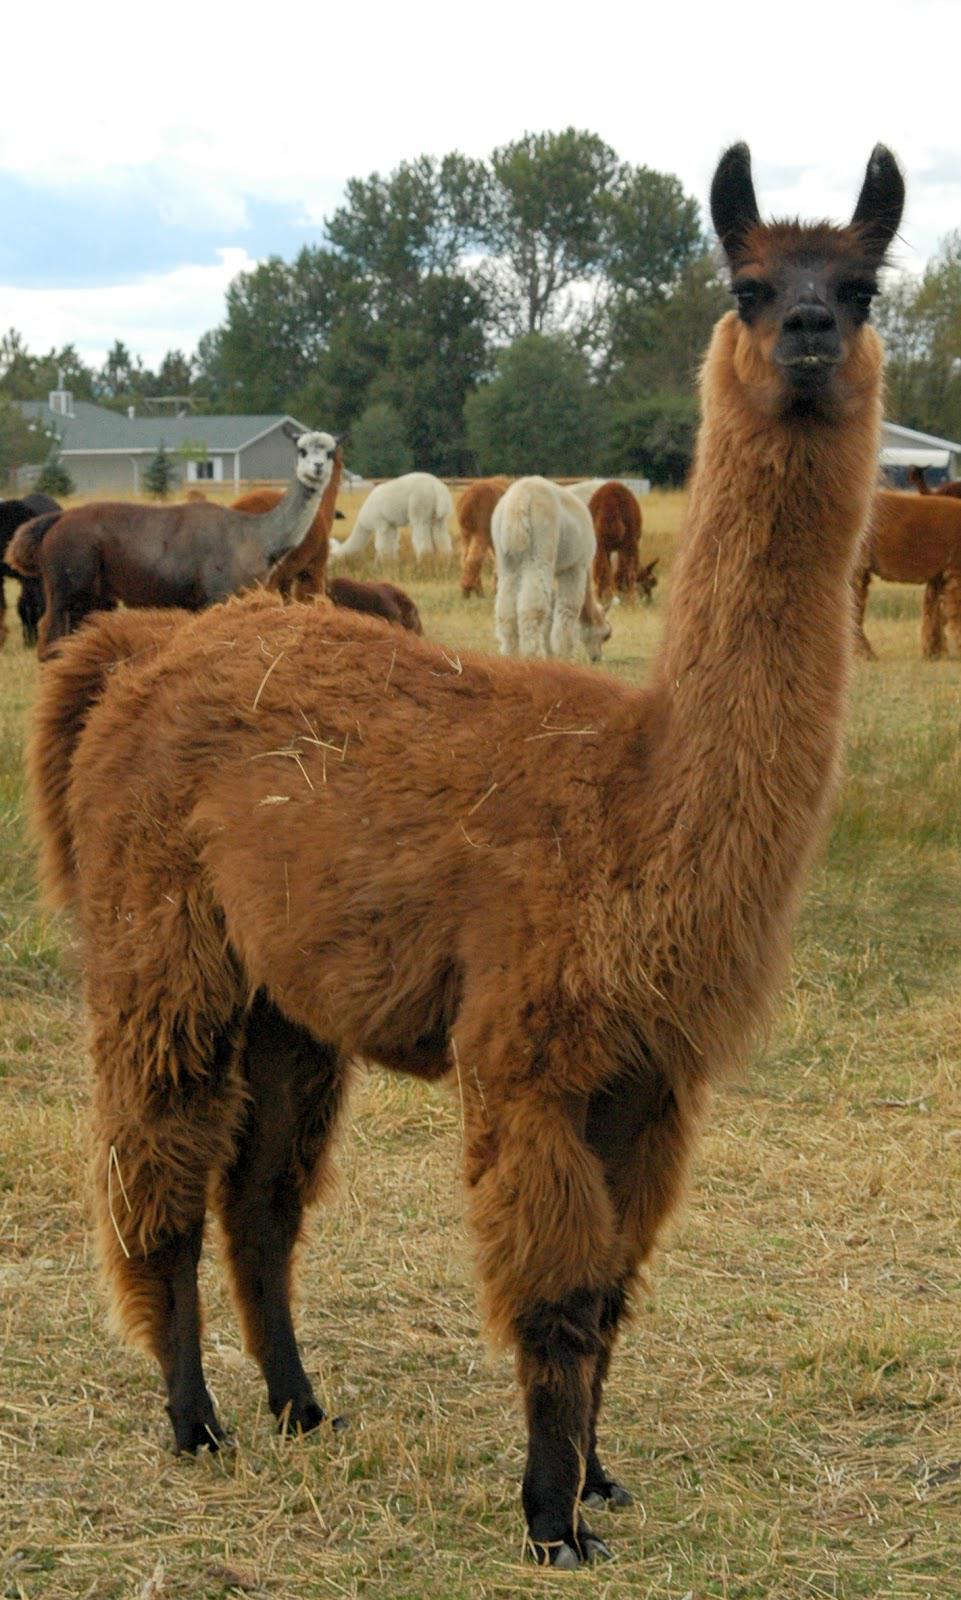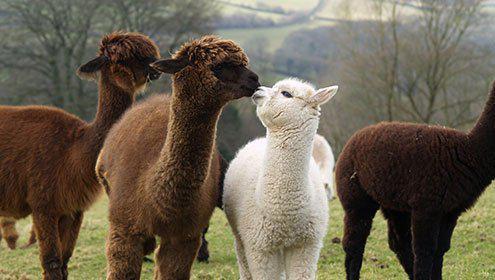The first image is the image on the left, the second image is the image on the right. Given the left and right images, does the statement "At least one photo shows an animal that has had the hair on its neck shaved, and every photo has at least three animals." hold true? Answer yes or no. No. The first image is the image on the left, the second image is the image on the right. Given the left and right images, does the statement "At least some of the llamas have shaved necks." hold true? Answer yes or no. No. 